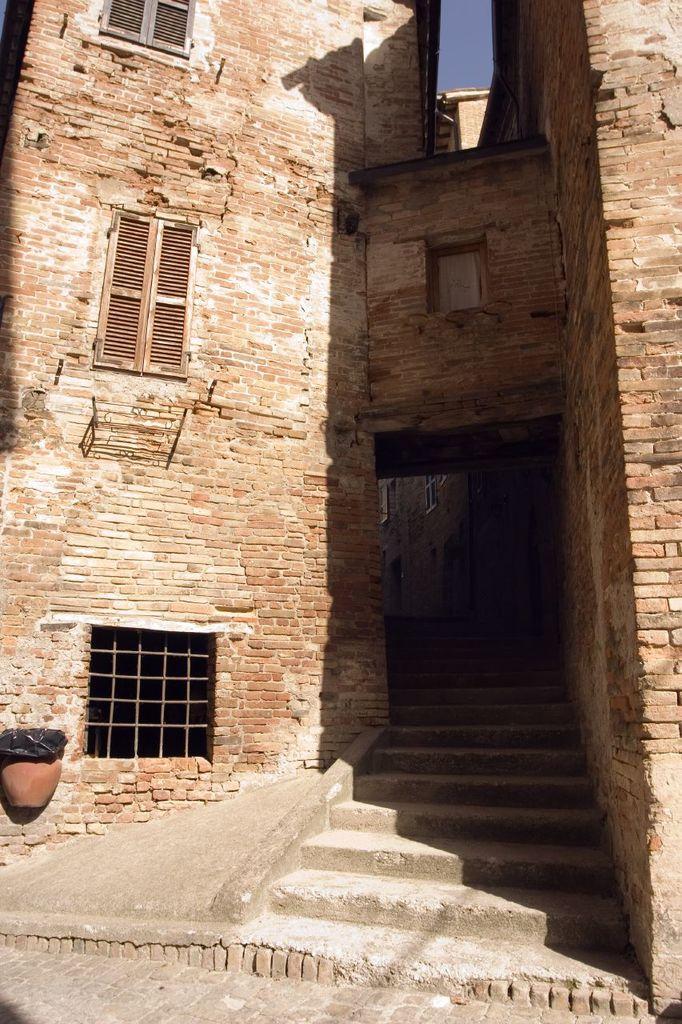Please provide a concise description of this image. In this image we can see a building and few windows attached to it. There is a pot and an object of black in color in the image. 